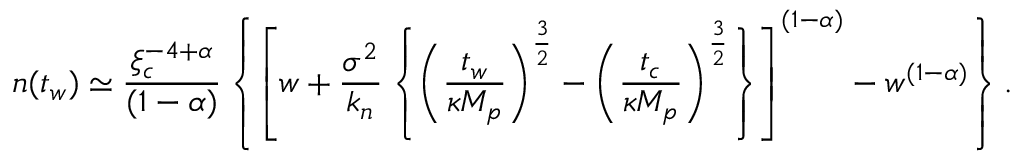<formula> <loc_0><loc_0><loc_500><loc_500>n ( t _ { w } ) \simeq { \frac { \xi _ { c } ^ { - 4 + \alpha } } { ( 1 - \alpha ) } } \left \{ \left [ w + { \frac { \sigma ^ { 2 } } { k _ { n } } } \left \{ \left ( { \frac { t _ { w } } { \kappa M _ { p } } } \right ) ^ { \frac { 3 } { 2 } } - \left ( { \frac { t _ { c } } { \kappa M _ { p } } } \right ) ^ { \frac { 3 } { 2 } } \right \} \right ] ^ { ( 1 - \alpha ) } - w ^ { ( 1 - \alpha ) } \right \} .</formula> 